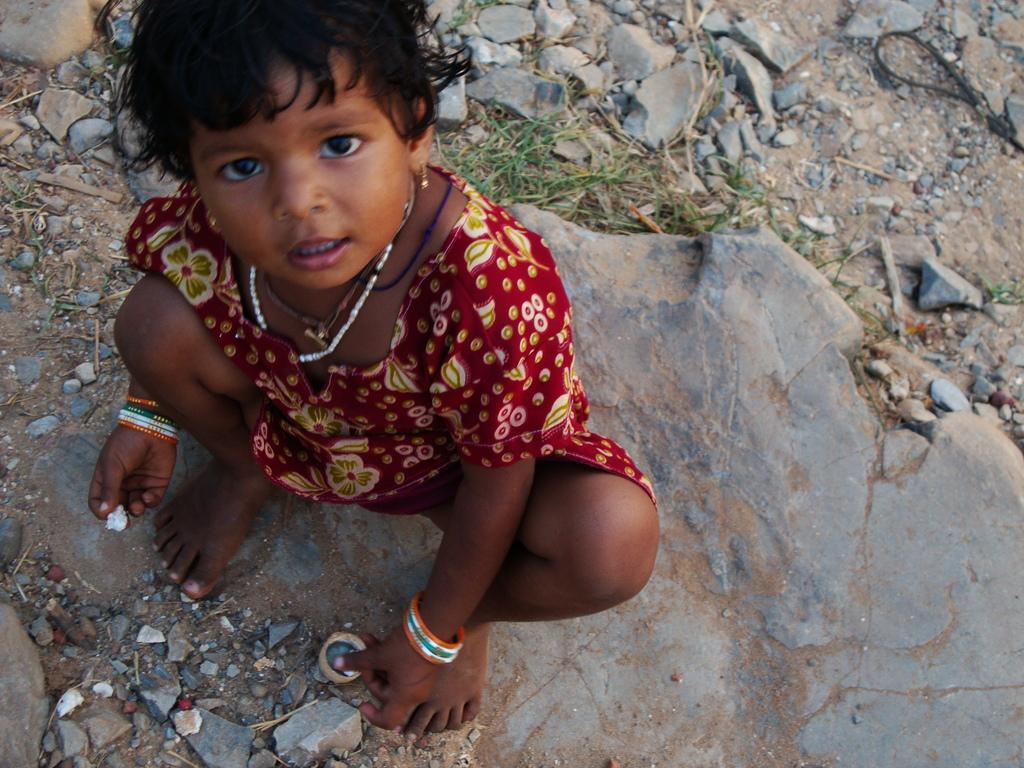Who is the main subject in the image? There is a girl in the image. What is the girl wearing? The girl is wearing a red dress. What is the girl doing in the image? The girl is sitting. What is the girl holding in the image? The girl is holding an object. What type of terrain is visible at the bottom of the image? There is grass at the bottom of the image. What other elements can be seen in the image? There are stones in the image. What type of square object is the girl's father holding in the image? There is no mention of a father or any square object in the image. 